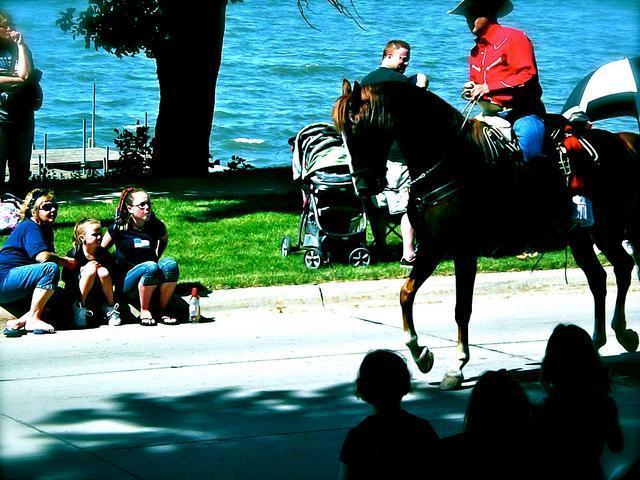How many horses are in the photo?
Give a very brief answer. 1. How many people are visible?
Give a very brief answer. 8. 